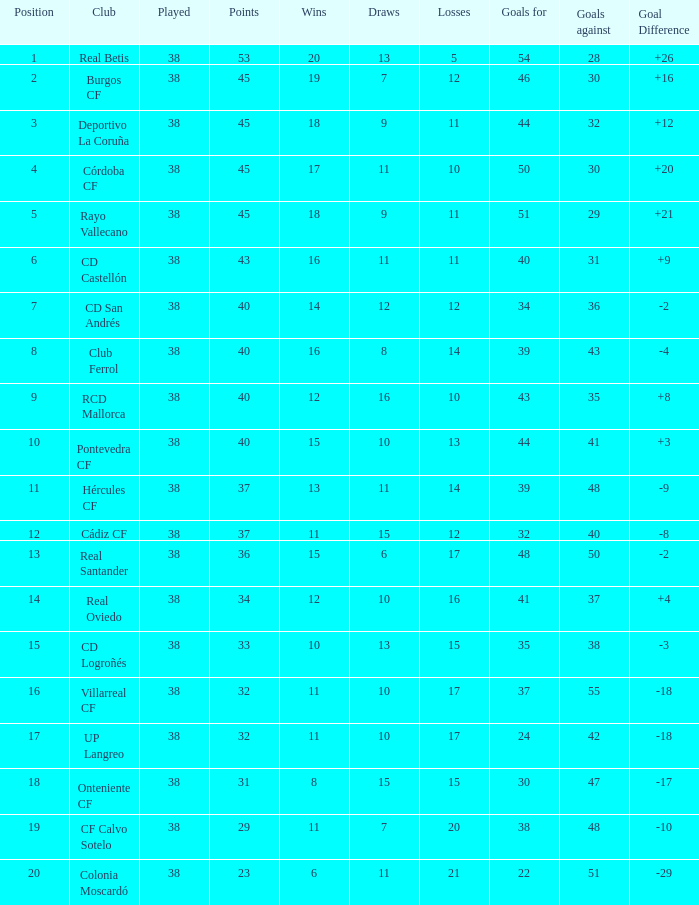What is the average Played, when Club is "Burgos CF", and when Draws is less than 7? None. 